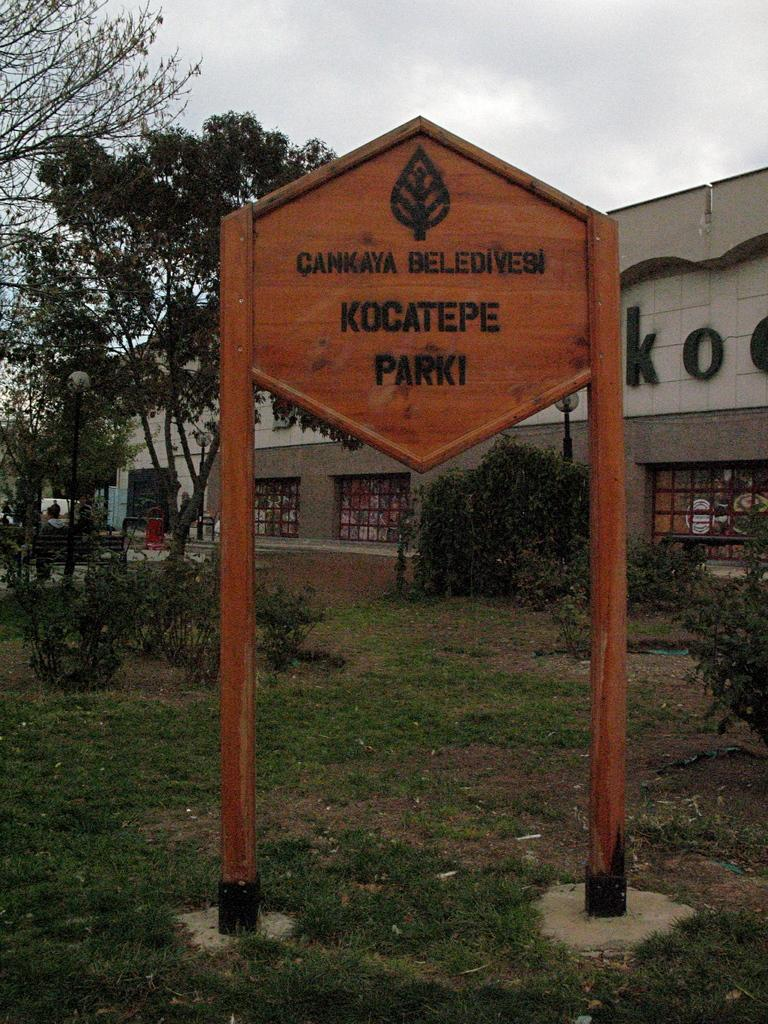What is located in the middle of the image? There is a board in the middle of the image. What can be seen in the background of the image? There are trees and a building in the background of the image. What is visible at the top of the image? The sky is visible at the top of the image. What type of humor can be seen in the image? There is no humor present in the image; it features a board, trees, a building, and the sky. Can you tell me how many police officers are visible in the image? There are no police officers present in the image. 